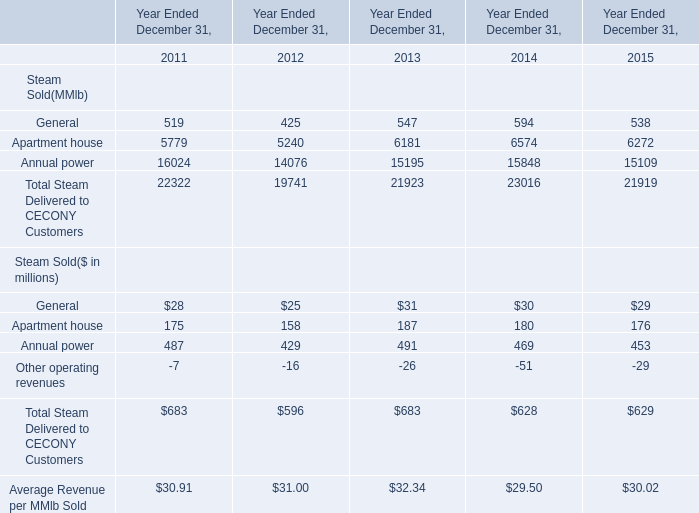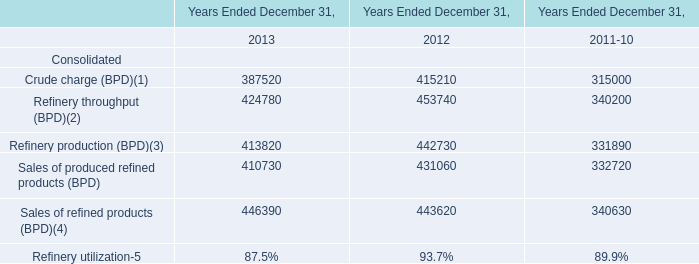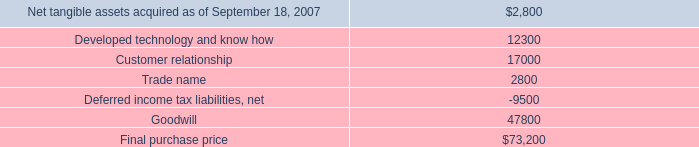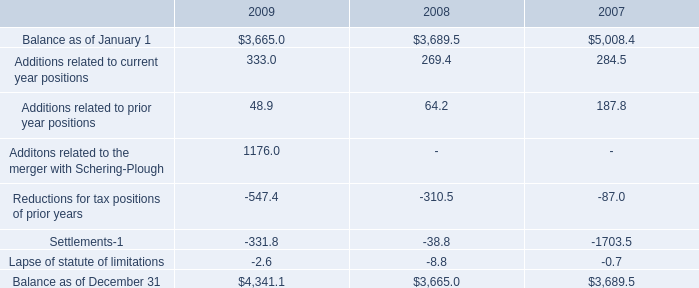In which year is General for Steam Sold(MMlb) greater than 590? 
Answer: 2014. 